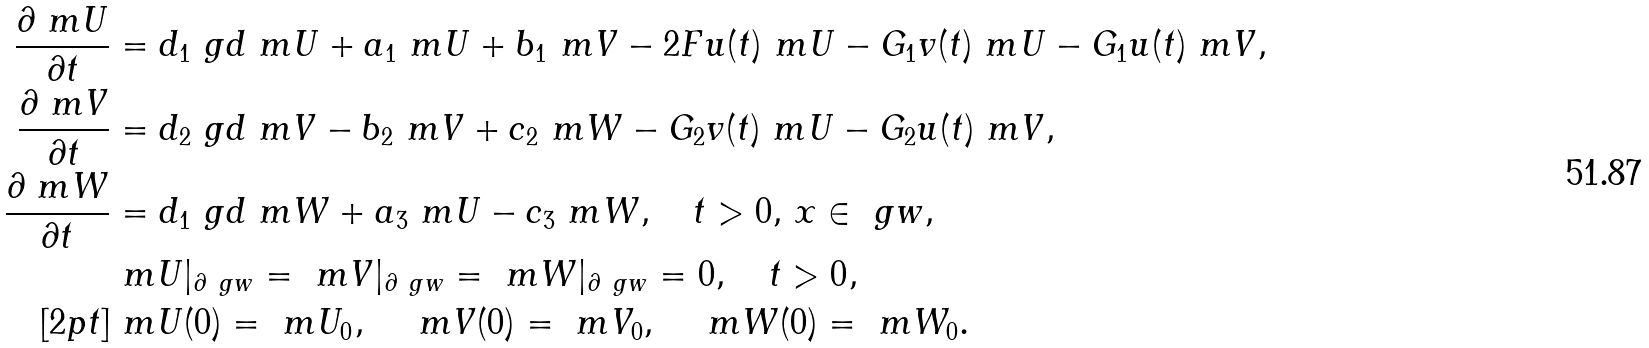Convert formula to latex. <formula><loc_0><loc_0><loc_500><loc_500>\frac { \partial \ m U } { \partial t } & = d _ { 1 } \ g d \ m U + a _ { 1 } \ m U + b _ { 1 } \ m V - 2 F u ( t ) \ m U - G _ { 1 } v ( t ) \ m U - G _ { 1 } u ( t ) \ m V , \\ \frac { \partial \ m V } { \partial t } & = d _ { 2 } \ g d \ m V - b _ { 2 } \ m V + c _ { 2 } \ m W - G _ { 2 } v ( t ) \ m U - G _ { 2 } u ( t ) \ m V , \\ \frac { \partial \ m W } { \partial t } & = d _ { 1 } \ g d \ m W + a _ { 3 } \ m U - c _ { 3 } \ m W , \quad t > 0 , \, x \in \ g w , \\ & \ m U | _ { \partial \ g w } = \ m V | _ { \partial \ g w } = \ m W | _ { \partial \ g w } = 0 , \quad t > 0 , \\ [ 2 p t ] & \ m U ( 0 ) = \ m U _ { 0 } , \quad \ m V ( 0 ) = \ m V _ { 0 } , \quad \ m W ( 0 ) = \ m W _ { 0 } .</formula> 